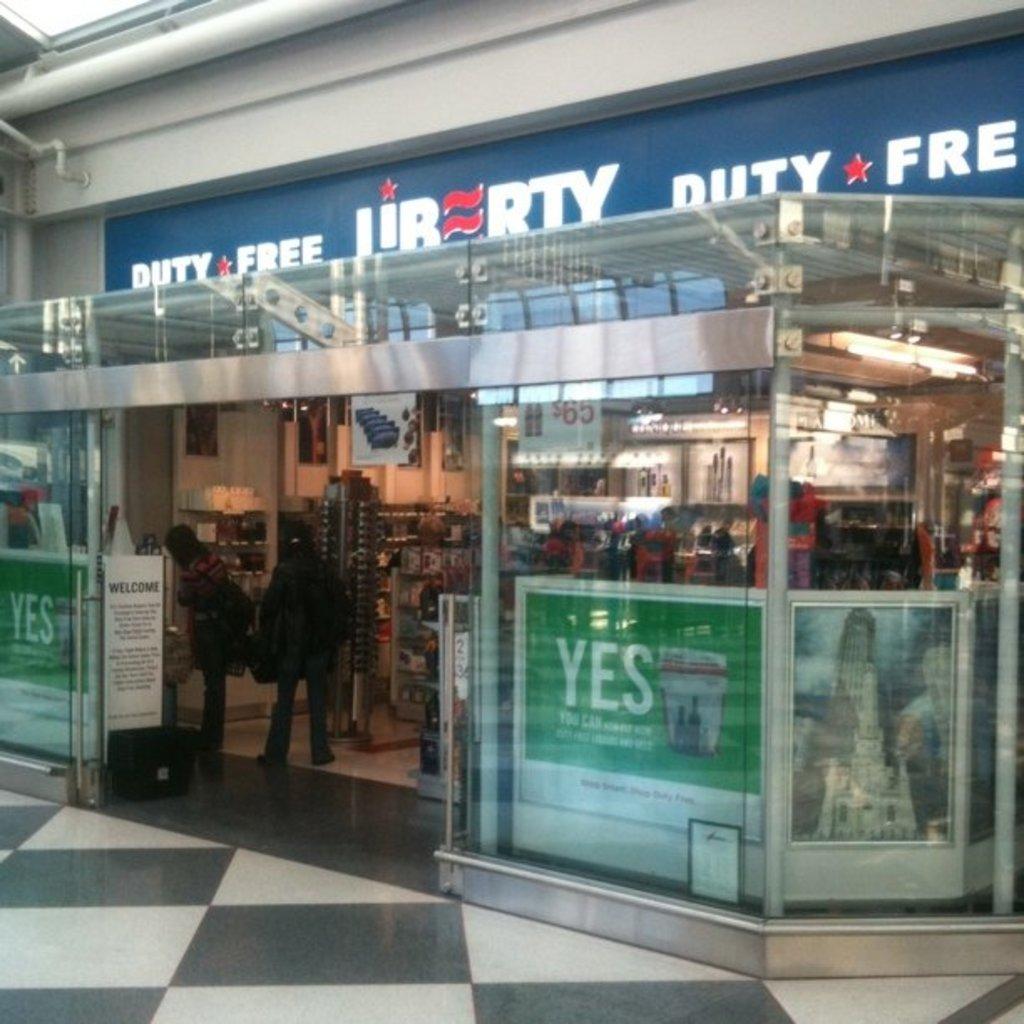What type of store is this?
Give a very brief answer. Duty free. What 3 letter word in on the green sign?
Give a very brief answer. Yes. 